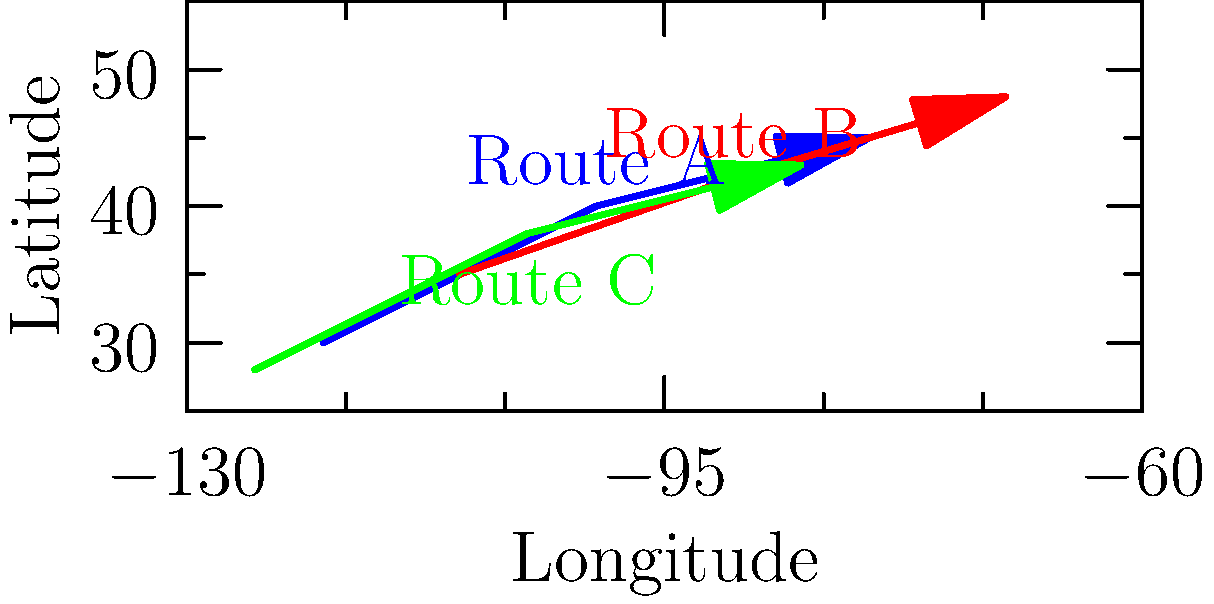Three different salamander species migrate along distinct routes across North America. Their migration paths are plotted on a coordinate system using latitude and longitude. Route A starts at $(-120°, 30°)$ and ends at $(-80°, 45°)$. Route B starts at $(-110°, 35°)$ and ends at $(-70°, 48°)$. Route C starts at $(-125°, 28°)$ and ends at $(-85°, 43°)$. Which route covers the greatest change in latitude? To determine which route covers the greatest change in latitude, we need to calculate the difference between the starting and ending latitudes for each route:

1. Route A:
   Start: $30°$, End: $45°$
   Change in latitude = $45° - 30° = 15°$

2. Route B:
   Start: $35°$, End: $48°$
   Change in latitude = $48° - 35° = 13°$

3. Route C:
   Start: $28°$, End: $43°$
   Change in latitude = $43° - 28° = 15°$

Both Route A and Route C have a change in latitude of $15°$, which is greater than Route B's $13°$. Therefore, Routes A and C tie for the greatest change in latitude.
Answer: Routes A and C (tie) 